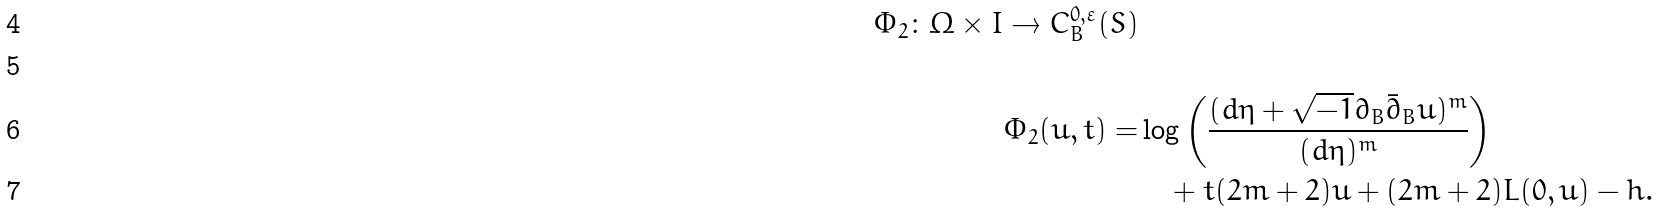Convert formula to latex. <formula><loc_0><loc_0><loc_500><loc_500>\Phi _ { 2 } \colon \Omega \times I \rightarrow C ^ { 0 , \varepsilon } _ { B } ( S ) \\ \\ \Phi _ { 2 } ( u , t ) = & \log \left ( \frac { ( d \eta + \sqrt { - 1 } \partial _ { B } \bar { \partial } _ { B } u ) ^ { m } } { ( d \eta ) ^ { m } } \right ) \\ & \quad + t ( 2 m + 2 ) u + ( 2 m + 2 ) L ( 0 , u ) - h .</formula> 